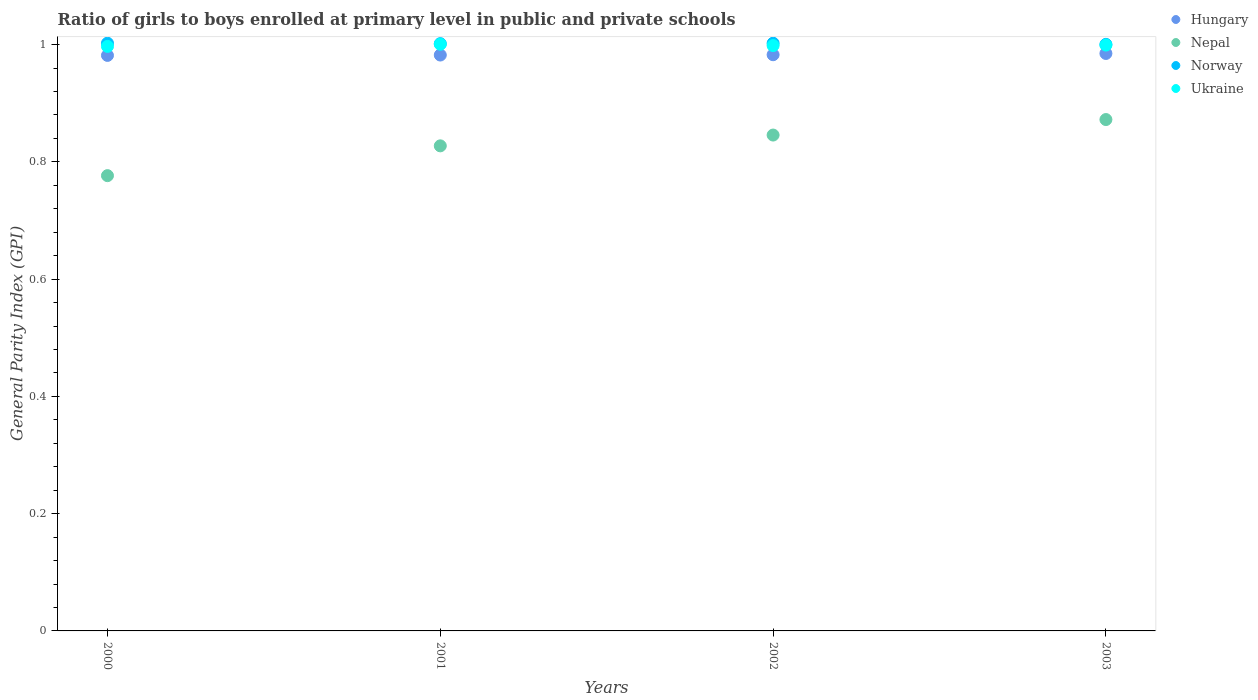How many different coloured dotlines are there?
Make the answer very short. 4. Is the number of dotlines equal to the number of legend labels?
Keep it short and to the point. Yes. What is the general parity index in Nepal in 2003?
Provide a short and direct response. 0.87. Across all years, what is the maximum general parity index in Nepal?
Give a very brief answer. 0.87. Across all years, what is the minimum general parity index in Norway?
Provide a succinct answer. 1. In which year was the general parity index in Ukraine minimum?
Your answer should be compact. 2000. What is the total general parity index in Norway in the graph?
Provide a succinct answer. 4.01. What is the difference between the general parity index in Nepal in 2000 and that in 2003?
Provide a succinct answer. -0.1. What is the difference between the general parity index in Ukraine in 2002 and the general parity index in Hungary in 2001?
Ensure brevity in your answer.  0.02. What is the average general parity index in Ukraine per year?
Your answer should be compact. 1. In the year 2003, what is the difference between the general parity index in Nepal and general parity index in Hungary?
Your answer should be compact. -0.11. What is the ratio of the general parity index in Hungary in 2000 to that in 2001?
Offer a terse response. 1. Is the difference between the general parity index in Nepal in 2000 and 2002 greater than the difference between the general parity index in Hungary in 2000 and 2002?
Give a very brief answer. No. What is the difference between the highest and the second highest general parity index in Hungary?
Keep it short and to the point. 0. What is the difference between the highest and the lowest general parity index in Nepal?
Give a very brief answer. 0.1. Is it the case that in every year, the sum of the general parity index in Ukraine and general parity index in Hungary  is greater than the sum of general parity index in Nepal and general parity index in Norway?
Your answer should be very brief. Yes. Is it the case that in every year, the sum of the general parity index in Hungary and general parity index in Norway  is greater than the general parity index in Nepal?
Your answer should be compact. Yes. How many years are there in the graph?
Keep it short and to the point. 4. Does the graph contain grids?
Give a very brief answer. No. How many legend labels are there?
Provide a short and direct response. 4. How are the legend labels stacked?
Offer a terse response. Vertical. What is the title of the graph?
Make the answer very short. Ratio of girls to boys enrolled at primary level in public and private schools. What is the label or title of the Y-axis?
Provide a succinct answer. General Parity Index (GPI). What is the General Parity Index (GPI) in Hungary in 2000?
Provide a succinct answer. 0.98. What is the General Parity Index (GPI) in Nepal in 2000?
Your answer should be compact. 0.78. What is the General Parity Index (GPI) of Norway in 2000?
Ensure brevity in your answer.  1. What is the General Parity Index (GPI) of Ukraine in 2000?
Give a very brief answer. 1. What is the General Parity Index (GPI) of Hungary in 2001?
Make the answer very short. 0.98. What is the General Parity Index (GPI) of Nepal in 2001?
Make the answer very short. 0.83. What is the General Parity Index (GPI) of Norway in 2001?
Your response must be concise. 1. What is the General Parity Index (GPI) in Ukraine in 2001?
Your response must be concise. 1. What is the General Parity Index (GPI) of Hungary in 2002?
Your response must be concise. 0.98. What is the General Parity Index (GPI) in Nepal in 2002?
Your answer should be very brief. 0.85. What is the General Parity Index (GPI) in Norway in 2002?
Your response must be concise. 1. What is the General Parity Index (GPI) of Ukraine in 2002?
Offer a very short reply. 1. What is the General Parity Index (GPI) of Hungary in 2003?
Give a very brief answer. 0.98. What is the General Parity Index (GPI) of Nepal in 2003?
Make the answer very short. 0.87. What is the General Parity Index (GPI) in Norway in 2003?
Provide a short and direct response. 1. What is the General Parity Index (GPI) of Ukraine in 2003?
Keep it short and to the point. 1. Across all years, what is the maximum General Parity Index (GPI) in Hungary?
Your response must be concise. 0.98. Across all years, what is the maximum General Parity Index (GPI) in Nepal?
Your answer should be compact. 0.87. Across all years, what is the maximum General Parity Index (GPI) in Norway?
Offer a terse response. 1. Across all years, what is the maximum General Parity Index (GPI) in Ukraine?
Offer a terse response. 1. Across all years, what is the minimum General Parity Index (GPI) in Hungary?
Provide a short and direct response. 0.98. Across all years, what is the minimum General Parity Index (GPI) of Nepal?
Your answer should be very brief. 0.78. Across all years, what is the minimum General Parity Index (GPI) in Norway?
Ensure brevity in your answer.  1. Across all years, what is the minimum General Parity Index (GPI) of Ukraine?
Provide a succinct answer. 1. What is the total General Parity Index (GPI) in Hungary in the graph?
Ensure brevity in your answer.  3.93. What is the total General Parity Index (GPI) in Nepal in the graph?
Make the answer very short. 3.32. What is the total General Parity Index (GPI) in Norway in the graph?
Make the answer very short. 4.01. What is the total General Parity Index (GPI) in Ukraine in the graph?
Your answer should be compact. 3.99. What is the difference between the General Parity Index (GPI) of Hungary in 2000 and that in 2001?
Offer a terse response. -0. What is the difference between the General Parity Index (GPI) of Nepal in 2000 and that in 2001?
Provide a succinct answer. -0.05. What is the difference between the General Parity Index (GPI) of Norway in 2000 and that in 2001?
Keep it short and to the point. 0. What is the difference between the General Parity Index (GPI) in Ukraine in 2000 and that in 2001?
Offer a terse response. -0. What is the difference between the General Parity Index (GPI) of Hungary in 2000 and that in 2002?
Ensure brevity in your answer.  -0. What is the difference between the General Parity Index (GPI) in Nepal in 2000 and that in 2002?
Make the answer very short. -0.07. What is the difference between the General Parity Index (GPI) in Ukraine in 2000 and that in 2002?
Offer a very short reply. -0. What is the difference between the General Parity Index (GPI) in Hungary in 2000 and that in 2003?
Your response must be concise. -0. What is the difference between the General Parity Index (GPI) of Nepal in 2000 and that in 2003?
Offer a terse response. -0.1. What is the difference between the General Parity Index (GPI) of Norway in 2000 and that in 2003?
Give a very brief answer. 0. What is the difference between the General Parity Index (GPI) in Ukraine in 2000 and that in 2003?
Offer a very short reply. -0. What is the difference between the General Parity Index (GPI) in Hungary in 2001 and that in 2002?
Provide a short and direct response. -0. What is the difference between the General Parity Index (GPI) of Nepal in 2001 and that in 2002?
Your answer should be compact. -0.02. What is the difference between the General Parity Index (GPI) of Norway in 2001 and that in 2002?
Your answer should be very brief. -0. What is the difference between the General Parity Index (GPI) of Ukraine in 2001 and that in 2002?
Offer a very short reply. 0. What is the difference between the General Parity Index (GPI) in Hungary in 2001 and that in 2003?
Make the answer very short. -0. What is the difference between the General Parity Index (GPI) of Nepal in 2001 and that in 2003?
Give a very brief answer. -0.04. What is the difference between the General Parity Index (GPI) of Norway in 2001 and that in 2003?
Provide a short and direct response. 0. What is the difference between the General Parity Index (GPI) of Ukraine in 2001 and that in 2003?
Give a very brief answer. 0. What is the difference between the General Parity Index (GPI) of Hungary in 2002 and that in 2003?
Keep it short and to the point. -0. What is the difference between the General Parity Index (GPI) in Nepal in 2002 and that in 2003?
Your answer should be compact. -0.03. What is the difference between the General Parity Index (GPI) in Norway in 2002 and that in 2003?
Your response must be concise. 0. What is the difference between the General Parity Index (GPI) in Ukraine in 2002 and that in 2003?
Your answer should be compact. -0. What is the difference between the General Parity Index (GPI) in Hungary in 2000 and the General Parity Index (GPI) in Nepal in 2001?
Give a very brief answer. 0.15. What is the difference between the General Parity Index (GPI) in Hungary in 2000 and the General Parity Index (GPI) in Norway in 2001?
Provide a succinct answer. -0.02. What is the difference between the General Parity Index (GPI) of Hungary in 2000 and the General Parity Index (GPI) of Ukraine in 2001?
Your response must be concise. -0.02. What is the difference between the General Parity Index (GPI) in Nepal in 2000 and the General Parity Index (GPI) in Norway in 2001?
Offer a terse response. -0.23. What is the difference between the General Parity Index (GPI) of Nepal in 2000 and the General Parity Index (GPI) of Ukraine in 2001?
Offer a terse response. -0.22. What is the difference between the General Parity Index (GPI) of Norway in 2000 and the General Parity Index (GPI) of Ukraine in 2001?
Make the answer very short. 0. What is the difference between the General Parity Index (GPI) of Hungary in 2000 and the General Parity Index (GPI) of Nepal in 2002?
Keep it short and to the point. 0.14. What is the difference between the General Parity Index (GPI) in Hungary in 2000 and the General Parity Index (GPI) in Norway in 2002?
Give a very brief answer. -0.02. What is the difference between the General Parity Index (GPI) in Hungary in 2000 and the General Parity Index (GPI) in Ukraine in 2002?
Keep it short and to the point. -0.02. What is the difference between the General Parity Index (GPI) of Nepal in 2000 and the General Parity Index (GPI) of Norway in 2002?
Provide a succinct answer. -0.23. What is the difference between the General Parity Index (GPI) of Nepal in 2000 and the General Parity Index (GPI) of Ukraine in 2002?
Your answer should be compact. -0.22. What is the difference between the General Parity Index (GPI) of Norway in 2000 and the General Parity Index (GPI) of Ukraine in 2002?
Provide a succinct answer. 0. What is the difference between the General Parity Index (GPI) of Hungary in 2000 and the General Parity Index (GPI) of Nepal in 2003?
Your response must be concise. 0.11. What is the difference between the General Parity Index (GPI) in Hungary in 2000 and the General Parity Index (GPI) in Norway in 2003?
Offer a terse response. -0.02. What is the difference between the General Parity Index (GPI) in Hungary in 2000 and the General Parity Index (GPI) in Ukraine in 2003?
Your answer should be compact. -0.02. What is the difference between the General Parity Index (GPI) of Nepal in 2000 and the General Parity Index (GPI) of Norway in 2003?
Your response must be concise. -0.22. What is the difference between the General Parity Index (GPI) of Nepal in 2000 and the General Parity Index (GPI) of Ukraine in 2003?
Provide a short and direct response. -0.22. What is the difference between the General Parity Index (GPI) in Norway in 2000 and the General Parity Index (GPI) in Ukraine in 2003?
Offer a very short reply. 0. What is the difference between the General Parity Index (GPI) of Hungary in 2001 and the General Parity Index (GPI) of Nepal in 2002?
Offer a very short reply. 0.14. What is the difference between the General Parity Index (GPI) in Hungary in 2001 and the General Parity Index (GPI) in Norway in 2002?
Ensure brevity in your answer.  -0.02. What is the difference between the General Parity Index (GPI) in Hungary in 2001 and the General Parity Index (GPI) in Ukraine in 2002?
Your answer should be compact. -0.02. What is the difference between the General Parity Index (GPI) of Nepal in 2001 and the General Parity Index (GPI) of Norway in 2002?
Provide a short and direct response. -0.17. What is the difference between the General Parity Index (GPI) of Nepal in 2001 and the General Parity Index (GPI) of Ukraine in 2002?
Make the answer very short. -0.17. What is the difference between the General Parity Index (GPI) in Norway in 2001 and the General Parity Index (GPI) in Ukraine in 2002?
Provide a short and direct response. 0. What is the difference between the General Parity Index (GPI) of Hungary in 2001 and the General Parity Index (GPI) of Nepal in 2003?
Give a very brief answer. 0.11. What is the difference between the General Parity Index (GPI) in Hungary in 2001 and the General Parity Index (GPI) in Norway in 2003?
Ensure brevity in your answer.  -0.02. What is the difference between the General Parity Index (GPI) of Hungary in 2001 and the General Parity Index (GPI) of Ukraine in 2003?
Your answer should be compact. -0.02. What is the difference between the General Parity Index (GPI) in Nepal in 2001 and the General Parity Index (GPI) in Norway in 2003?
Keep it short and to the point. -0.17. What is the difference between the General Parity Index (GPI) in Nepal in 2001 and the General Parity Index (GPI) in Ukraine in 2003?
Your answer should be compact. -0.17. What is the difference between the General Parity Index (GPI) in Norway in 2001 and the General Parity Index (GPI) in Ukraine in 2003?
Ensure brevity in your answer.  0. What is the difference between the General Parity Index (GPI) of Hungary in 2002 and the General Parity Index (GPI) of Nepal in 2003?
Make the answer very short. 0.11. What is the difference between the General Parity Index (GPI) in Hungary in 2002 and the General Parity Index (GPI) in Norway in 2003?
Your response must be concise. -0.02. What is the difference between the General Parity Index (GPI) in Hungary in 2002 and the General Parity Index (GPI) in Ukraine in 2003?
Keep it short and to the point. -0.02. What is the difference between the General Parity Index (GPI) of Nepal in 2002 and the General Parity Index (GPI) of Norway in 2003?
Keep it short and to the point. -0.15. What is the difference between the General Parity Index (GPI) in Nepal in 2002 and the General Parity Index (GPI) in Ukraine in 2003?
Your answer should be compact. -0.15. What is the difference between the General Parity Index (GPI) of Norway in 2002 and the General Parity Index (GPI) of Ukraine in 2003?
Make the answer very short. 0. What is the average General Parity Index (GPI) of Hungary per year?
Your answer should be compact. 0.98. What is the average General Parity Index (GPI) in Nepal per year?
Give a very brief answer. 0.83. What is the average General Parity Index (GPI) in Ukraine per year?
Offer a very short reply. 1. In the year 2000, what is the difference between the General Parity Index (GPI) in Hungary and General Parity Index (GPI) in Nepal?
Ensure brevity in your answer.  0.21. In the year 2000, what is the difference between the General Parity Index (GPI) in Hungary and General Parity Index (GPI) in Norway?
Offer a terse response. -0.02. In the year 2000, what is the difference between the General Parity Index (GPI) of Hungary and General Parity Index (GPI) of Ukraine?
Your answer should be compact. -0.02. In the year 2000, what is the difference between the General Parity Index (GPI) in Nepal and General Parity Index (GPI) in Norway?
Provide a succinct answer. -0.23. In the year 2000, what is the difference between the General Parity Index (GPI) in Nepal and General Parity Index (GPI) in Ukraine?
Your answer should be very brief. -0.22. In the year 2000, what is the difference between the General Parity Index (GPI) of Norway and General Parity Index (GPI) of Ukraine?
Your answer should be compact. 0.01. In the year 2001, what is the difference between the General Parity Index (GPI) in Hungary and General Parity Index (GPI) in Nepal?
Make the answer very short. 0.15. In the year 2001, what is the difference between the General Parity Index (GPI) in Hungary and General Parity Index (GPI) in Norway?
Keep it short and to the point. -0.02. In the year 2001, what is the difference between the General Parity Index (GPI) in Hungary and General Parity Index (GPI) in Ukraine?
Provide a short and direct response. -0.02. In the year 2001, what is the difference between the General Parity Index (GPI) in Nepal and General Parity Index (GPI) in Norway?
Provide a succinct answer. -0.17. In the year 2001, what is the difference between the General Parity Index (GPI) of Nepal and General Parity Index (GPI) of Ukraine?
Keep it short and to the point. -0.17. In the year 2001, what is the difference between the General Parity Index (GPI) in Norway and General Parity Index (GPI) in Ukraine?
Offer a terse response. 0. In the year 2002, what is the difference between the General Parity Index (GPI) in Hungary and General Parity Index (GPI) in Nepal?
Keep it short and to the point. 0.14. In the year 2002, what is the difference between the General Parity Index (GPI) of Hungary and General Parity Index (GPI) of Norway?
Your answer should be very brief. -0.02. In the year 2002, what is the difference between the General Parity Index (GPI) in Hungary and General Parity Index (GPI) in Ukraine?
Keep it short and to the point. -0.02. In the year 2002, what is the difference between the General Parity Index (GPI) of Nepal and General Parity Index (GPI) of Norway?
Your answer should be compact. -0.16. In the year 2002, what is the difference between the General Parity Index (GPI) in Nepal and General Parity Index (GPI) in Ukraine?
Your answer should be compact. -0.15. In the year 2002, what is the difference between the General Parity Index (GPI) in Norway and General Parity Index (GPI) in Ukraine?
Give a very brief answer. 0. In the year 2003, what is the difference between the General Parity Index (GPI) of Hungary and General Parity Index (GPI) of Nepal?
Your response must be concise. 0.11. In the year 2003, what is the difference between the General Parity Index (GPI) in Hungary and General Parity Index (GPI) in Norway?
Keep it short and to the point. -0.02. In the year 2003, what is the difference between the General Parity Index (GPI) in Hungary and General Parity Index (GPI) in Ukraine?
Your answer should be very brief. -0.01. In the year 2003, what is the difference between the General Parity Index (GPI) in Nepal and General Parity Index (GPI) in Norway?
Keep it short and to the point. -0.13. In the year 2003, what is the difference between the General Parity Index (GPI) in Nepal and General Parity Index (GPI) in Ukraine?
Ensure brevity in your answer.  -0.13. In the year 2003, what is the difference between the General Parity Index (GPI) of Norway and General Parity Index (GPI) of Ukraine?
Give a very brief answer. 0. What is the ratio of the General Parity Index (GPI) of Hungary in 2000 to that in 2001?
Offer a terse response. 1. What is the ratio of the General Parity Index (GPI) of Nepal in 2000 to that in 2001?
Ensure brevity in your answer.  0.94. What is the ratio of the General Parity Index (GPI) in Norway in 2000 to that in 2001?
Provide a succinct answer. 1. What is the ratio of the General Parity Index (GPI) in Nepal in 2000 to that in 2002?
Your answer should be compact. 0.92. What is the ratio of the General Parity Index (GPI) of Hungary in 2000 to that in 2003?
Your response must be concise. 1. What is the ratio of the General Parity Index (GPI) of Nepal in 2000 to that in 2003?
Provide a succinct answer. 0.89. What is the ratio of the General Parity Index (GPI) of Ukraine in 2000 to that in 2003?
Your response must be concise. 1. What is the ratio of the General Parity Index (GPI) in Hungary in 2001 to that in 2002?
Ensure brevity in your answer.  1. What is the ratio of the General Parity Index (GPI) of Nepal in 2001 to that in 2002?
Your response must be concise. 0.98. What is the ratio of the General Parity Index (GPI) of Nepal in 2001 to that in 2003?
Give a very brief answer. 0.95. What is the ratio of the General Parity Index (GPI) of Hungary in 2002 to that in 2003?
Provide a succinct answer. 1. What is the ratio of the General Parity Index (GPI) of Nepal in 2002 to that in 2003?
Your response must be concise. 0.97. What is the ratio of the General Parity Index (GPI) in Norway in 2002 to that in 2003?
Offer a terse response. 1. What is the difference between the highest and the second highest General Parity Index (GPI) in Hungary?
Your answer should be very brief. 0. What is the difference between the highest and the second highest General Parity Index (GPI) in Nepal?
Keep it short and to the point. 0.03. What is the difference between the highest and the second highest General Parity Index (GPI) of Norway?
Give a very brief answer. 0. What is the difference between the highest and the second highest General Parity Index (GPI) of Ukraine?
Give a very brief answer. 0. What is the difference between the highest and the lowest General Parity Index (GPI) of Hungary?
Make the answer very short. 0. What is the difference between the highest and the lowest General Parity Index (GPI) of Nepal?
Your response must be concise. 0.1. What is the difference between the highest and the lowest General Parity Index (GPI) of Norway?
Give a very brief answer. 0. What is the difference between the highest and the lowest General Parity Index (GPI) in Ukraine?
Provide a short and direct response. 0. 